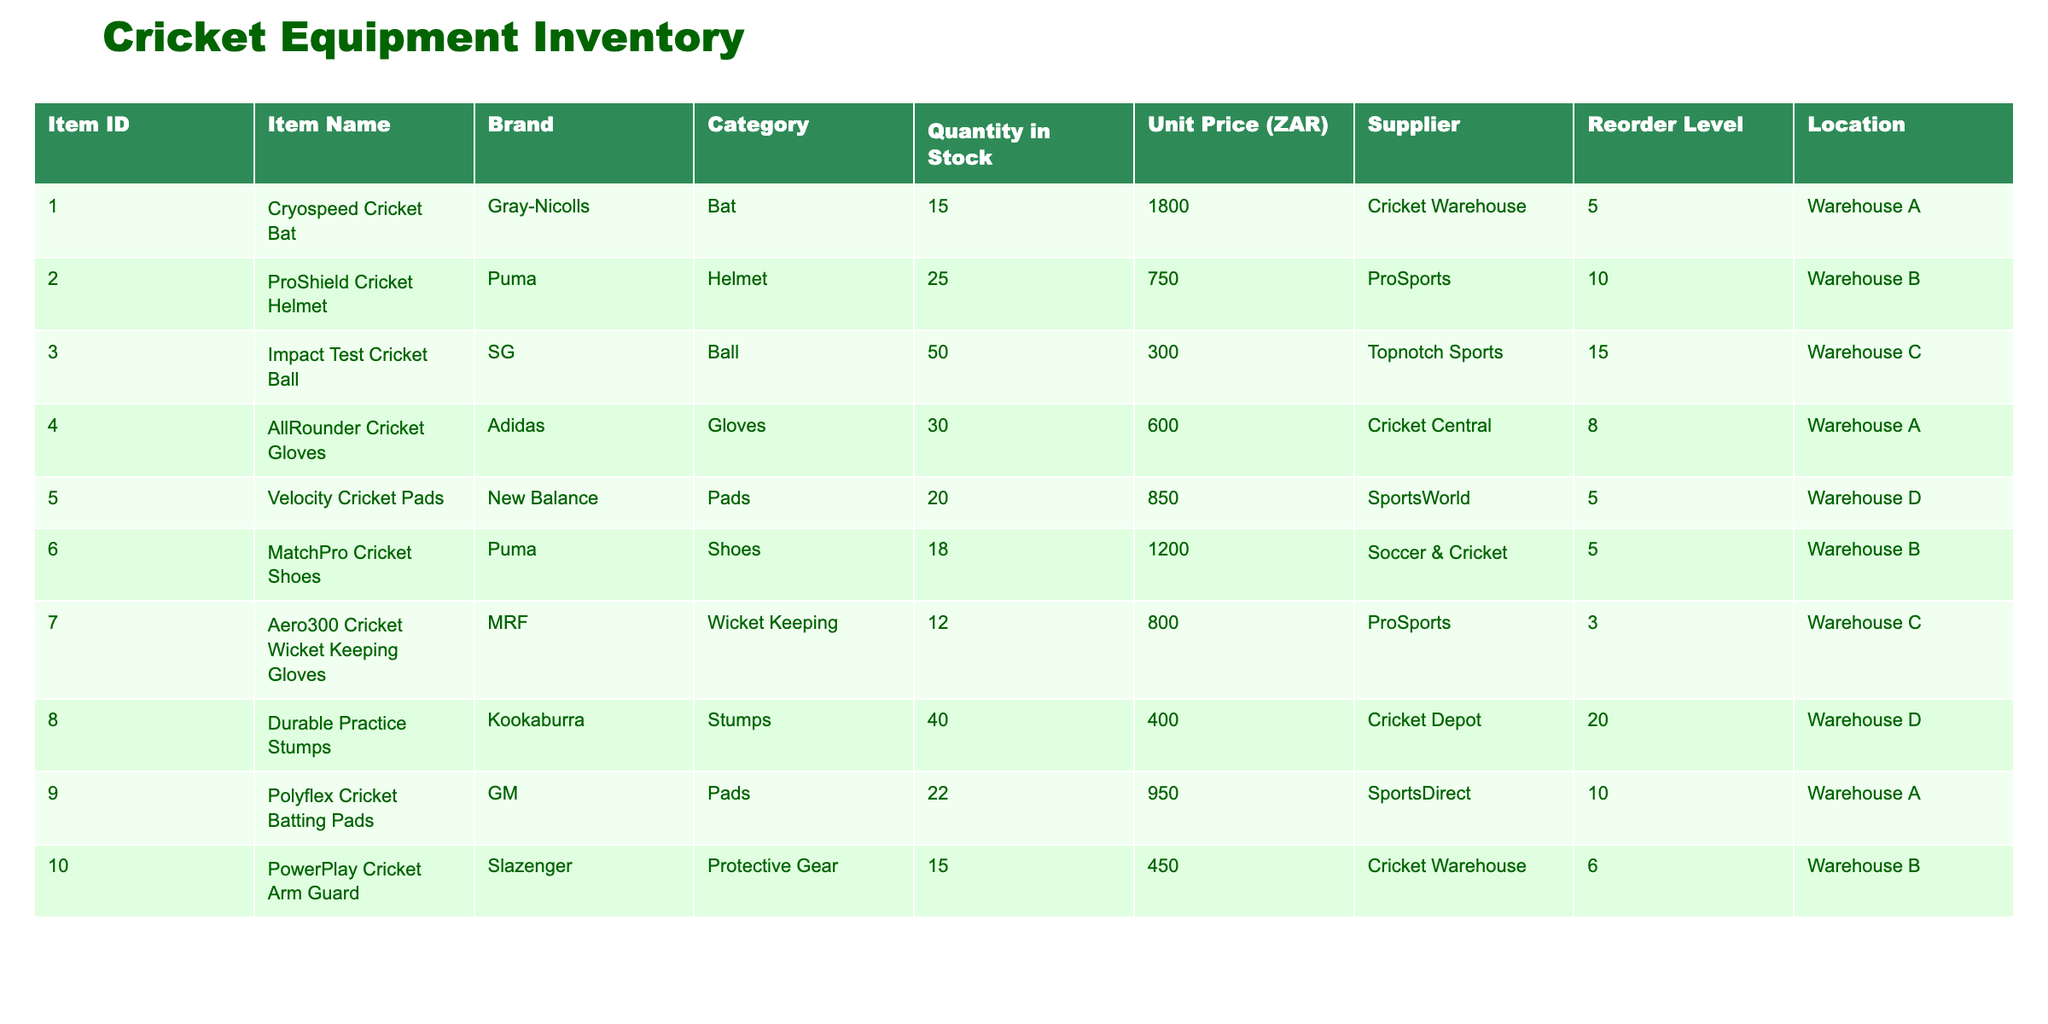What is the quantity of ProShield Cricket Helmets in stock? The table lists the item "ProShield Cricket Helmet" with an Item ID of 002 under the "Quantity in Stock" column, which shows 25 units.
Answer: 25 What is the unit price of the Aero300 Cricket Wicket Keeping Gloves? Looking at the table, the unit price for "Aero300 Cricket Wicket Keeping Gloves," which has Item ID 007, is 800 ZAR.
Answer: 800 ZAR Who supplies the Velocity Cricket Pads? The table indicates that "Velocity Cricket Pads," Item ID 005, is supplied by SportsWorld.
Answer: SportsWorld Is the quantity in stock for any stumps below their reorder level? "Durable Practice Stumps" have a current stock of 40, and their reorder level is 20, meaning they are above the reorder level. No other stumps are listed, so the answer is no.
Answer: No What is the total quantity of Pads in stock? To find the total, look at both "Velocity Cricket Pads" (20) and "Polyflex Cricket Batting Pads" (22). Summing these values gives 20 + 22 = 42.
Answer: 42 Which brand has the highest quantity of items in stock? Assessing the stock quantities, we have items from different brands: Gray-Nicolls (15), Puma (43), SG (50), Adidas (30), New Balance (20), MRF (12), Kookaburra (40), GM (22), and Slazenger (15). The highest is from SG with 50.
Answer: SG What is the average unit price of gloves in the inventory? The gloves listed are AllRounder Cricket Gloves (600 ZAR) and Aero300 Cricket Wicket Keeping Gloves (800 ZAR). Calculating the average: (600 + 800) / 2 = 700 ZAR.
Answer: 700 ZAR Are there more cricket balls in stock than cricket bats? "Impact Test Cricket Ball" has 50 in stock, while "Cryospeed Cricket Bat" has 15. Since 50 > 15, the answer is yes.
Answer: Yes How many items listed have a reorder level above 5? The items with reorder levels above 5 are: ProShield Cricket Helmet (10), Impact Test Cricket Ball (15), AllRounder Cricket Gloves (8), Velocity Cricket Pads (5), and Durable Practice Stumps (20). Counting these gives a total of 5 items.
Answer: 5 